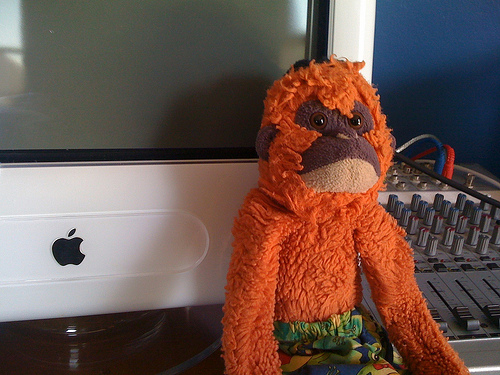<image>
Is there a toy in front of the computer? Yes. The toy is positioned in front of the computer, appearing closer to the camera viewpoint. Is the switch board to the left of the orangutan? Yes. From this viewpoint, the switch board is positioned to the left side relative to the orangutan. 